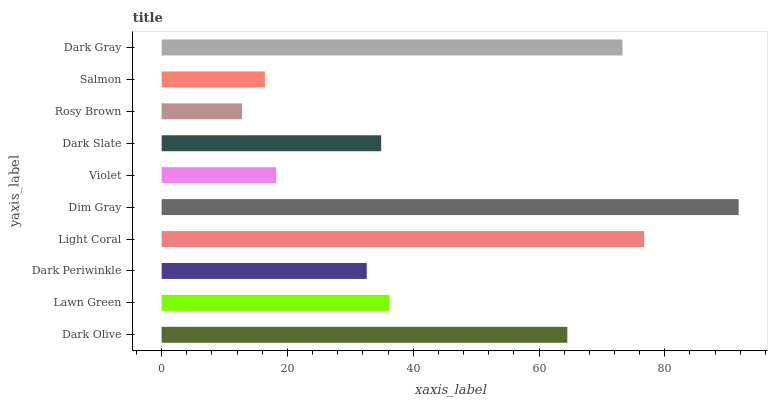Is Rosy Brown the minimum?
Answer yes or no. Yes. Is Dim Gray the maximum?
Answer yes or no. Yes. Is Lawn Green the minimum?
Answer yes or no. No. Is Lawn Green the maximum?
Answer yes or no. No. Is Dark Olive greater than Lawn Green?
Answer yes or no. Yes. Is Lawn Green less than Dark Olive?
Answer yes or no. Yes. Is Lawn Green greater than Dark Olive?
Answer yes or no. No. Is Dark Olive less than Lawn Green?
Answer yes or no. No. Is Lawn Green the high median?
Answer yes or no. Yes. Is Dark Slate the low median?
Answer yes or no. Yes. Is Dark Olive the high median?
Answer yes or no. No. Is Lawn Green the low median?
Answer yes or no. No. 